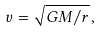Convert formula to latex. <formula><loc_0><loc_0><loc_500><loc_500>v = \sqrt { G M / r } \, ,</formula> 